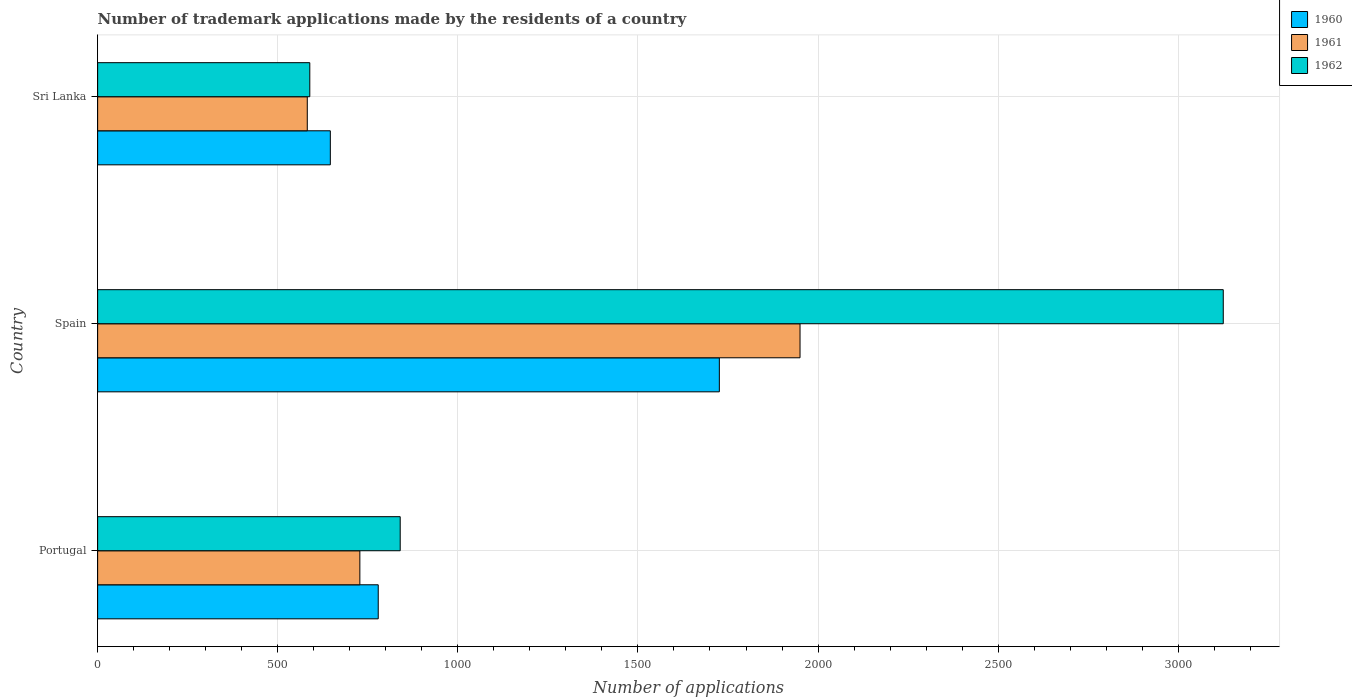How many different coloured bars are there?
Provide a short and direct response. 3. Are the number of bars per tick equal to the number of legend labels?
Ensure brevity in your answer.  Yes. Are the number of bars on each tick of the Y-axis equal?
Your answer should be compact. Yes. What is the label of the 3rd group of bars from the top?
Give a very brief answer. Portugal. In how many cases, is the number of bars for a given country not equal to the number of legend labels?
Offer a very short reply. 0. What is the number of trademark applications made by the residents in 1962 in Sri Lanka?
Offer a very short reply. 589. Across all countries, what is the maximum number of trademark applications made by the residents in 1962?
Ensure brevity in your answer.  3125. Across all countries, what is the minimum number of trademark applications made by the residents in 1962?
Offer a terse response. 589. In which country was the number of trademark applications made by the residents in 1962 maximum?
Ensure brevity in your answer.  Spain. In which country was the number of trademark applications made by the residents in 1961 minimum?
Make the answer very short. Sri Lanka. What is the total number of trademark applications made by the residents in 1961 in the graph?
Give a very brief answer. 3260. What is the difference between the number of trademark applications made by the residents in 1961 in Spain and that in Sri Lanka?
Provide a short and direct response. 1368. What is the difference between the number of trademark applications made by the residents in 1962 in Sri Lanka and the number of trademark applications made by the residents in 1960 in Portugal?
Provide a succinct answer. -190. What is the average number of trademark applications made by the residents in 1962 per country?
Provide a short and direct response. 1518. What is the difference between the number of trademark applications made by the residents in 1961 and number of trademark applications made by the residents in 1960 in Portugal?
Your answer should be very brief. -51. In how many countries, is the number of trademark applications made by the residents in 1962 greater than 1900 ?
Ensure brevity in your answer.  1. What is the ratio of the number of trademark applications made by the residents in 1961 in Portugal to that in Sri Lanka?
Keep it short and to the point. 1.25. Is the difference between the number of trademark applications made by the residents in 1961 in Spain and Sri Lanka greater than the difference between the number of trademark applications made by the residents in 1960 in Spain and Sri Lanka?
Keep it short and to the point. Yes. What is the difference between the highest and the second highest number of trademark applications made by the residents in 1960?
Ensure brevity in your answer.  947. What is the difference between the highest and the lowest number of trademark applications made by the residents in 1962?
Provide a short and direct response. 2536. In how many countries, is the number of trademark applications made by the residents in 1960 greater than the average number of trademark applications made by the residents in 1960 taken over all countries?
Your response must be concise. 1. Is the sum of the number of trademark applications made by the residents in 1962 in Portugal and Spain greater than the maximum number of trademark applications made by the residents in 1961 across all countries?
Your response must be concise. Yes. What does the 1st bar from the top in Spain represents?
Offer a very short reply. 1962. Is it the case that in every country, the sum of the number of trademark applications made by the residents in 1960 and number of trademark applications made by the residents in 1962 is greater than the number of trademark applications made by the residents in 1961?
Give a very brief answer. Yes. How many bars are there?
Your answer should be compact. 9. Are all the bars in the graph horizontal?
Your answer should be compact. Yes. What is the difference between two consecutive major ticks on the X-axis?
Make the answer very short. 500. Does the graph contain any zero values?
Give a very brief answer. No. Does the graph contain grids?
Offer a terse response. Yes. How many legend labels are there?
Your response must be concise. 3. What is the title of the graph?
Keep it short and to the point. Number of trademark applications made by the residents of a country. What is the label or title of the X-axis?
Your answer should be compact. Number of applications. What is the label or title of the Y-axis?
Give a very brief answer. Country. What is the Number of applications in 1960 in Portugal?
Keep it short and to the point. 779. What is the Number of applications of 1961 in Portugal?
Your answer should be very brief. 728. What is the Number of applications of 1962 in Portugal?
Offer a very short reply. 840. What is the Number of applications of 1960 in Spain?
Give a very brief answer. 1726. What is the Number of applications in 1961 in Spain?
Make the answer very short. 1950. What is the Number of applications in 1962 in Spain?
Ensure brevity in your answer.  3125. What is the Number of applications of 1960 in Sri Lanka?
Provide a short and direct response. 646. What is the Number of applications in 1961 in Sri Lanka?
Offer a very short reply. 582. What is the Number of applications of 1962 in Sri Lanka?
Ensure brevity in your answer.  589. Across all countries, what is the maximum Number of applications of 1960?
Make the answer very short. 1726. Across all countries, what is the maximum Number of applications of 1961?
Provide a succinct answer. 1950. Across all countries, what is the maximum Number of applications of 1962?
Your response must be concise. 3125. Across all countries, what is the minimum Number of applications in 1960?
Your answer should be very brief. 646. Across all countries, what is the minimum Number of applications in 1961?
Your answer should be compact. 582. Across all countries, what is the minimum Number of applications in 1962?
Your answer should be very brief. 589. What is the total Number of applications of 1960 in the graph?
Make the answer very short. 3151. What is the total Number of applications of 1961 in the graph?
Make the answer very short. 3260. What is the total Number of applications in 1962 in the graph?
Your response must be concise. 4554. What is the difference between the Number of applications in 1960 in Portugal and that in Spain?
Provide a short and direct response. -947. What is the difference between the Number of applications in 1961 in Portugal and that in Spain?
Provide a short and direct response. -1222. What is the difference between the Number of applications in 1962 in Portugal and that in Spain?
Offer a terse response. -2285. What is the difference between the Number of applications in 1960 in Portugal and that in Sri Lanka?
Keep it short and to the point. 133. What is the difference between the Number of applications in 1961 in Portugal and that in Sri Lanka?
Your response must be concise. 146. What is the difference between the Number of applications of 1962 in Portugal and that in Sri Lanka?
Offer a very short reply. 251. What is the difference between the Number of applications in 1960 in Spain and that in Sri Lanka?
Your answer should be compact. 1080. What is the difference between the Number of applications in 1961 in Spain and that in Sri Lanka?
Ensure brevity in your answer.  1368. What is the difference between the Number of applications in 1962 in Spain and that in Sri Lanka?
Offer a terse response. 2536. What is the difference between the Number of applications in 1960 in Portugal and the Number of applications in 1961 in Spain?
Your answer should be compact. -1171. What is the difference between the Number of applications of 1960 in Portugal and the Number of applications of 1962 in Spain?
Give a very brief answer. -2346. What is the difference between the Number of applications in 1961 in Portugal and the Number of applications in 1962 in Spain?
Your answer should be compact. -2397. What is the difference between the Number of applications in 1960 in Portugal and the Number of applications in 1961 in Sri Lanka?
Your answer should be very brief. 197. What is the difference between the Number of applications in 1960 in Portugal and the Number of applications in 1962 in Sri Lanka?
Give a very brief answer. 190. What is the difference between the Number of applications of 1961 in Portugal and the Number of applications of 1962 in Sri Lanka?
Keep it short and to the point. 139. What is the difference between the Number of applications of 1960 in Spain and the Number of applications of 1961 in Sri Lanka?
Give a very brief answer. 1144. What is the difference between the Number of applications in 1960 in Spain and the Number of applications in 1962 in Sri Lanka?
Make the answer very short. 1137. What is the difference between the Number of applications in 1961 in Spain and the Number of applications in 1962 in Sri Lanka?
Provide a short and direct response. 1361. What is the average Number of applications in 1960 per country?
Make the answer very short. 1050.33. What is the average Number of applications of 1961 per country?
Your response must be concise. 1086.67. What is the average Number of applications of 1962 per country?
Offer a terse response. 1518. What is the difference between the Number of applications in 1960 and Number of applications in 1962 in Portugal?
Keep it short and to the point. -61. What is the difference between the Number of applications of 1961 and Number of applications of 1962 in Portugal?
Ensure brevity in your answer.  -112. What is the difference between the Number of applications of 1960 and Number of applications of 1961 in Spain?
Provide a short and direct response. -224. What is the difference between the Number of applications of 1960 and Number of applications of 1962 in Spain?
Provide a short and direct response. -1399. What is the difference between the Number of applications of 1961 and Number of applications of 1962 in Spain?
Provide a short and direct response. -1175. What is the difference between the Number of applications in 1961 and Number of applications in 1962 in Sri Lanka?
Make the answer very short. -7. What is the ratio of the Number of applications in 1960 in Portugal to that in Spain?
Your answer should be compact. 0.45. What is the ratio of the Number of applications of 1961 in Portugal to that in Spain?
Offer a very short reply. 0.37. What is the ratio of the Number of applications of 1962 in Portugal to that in Spain?
Keep it short and to the point. 0.27. What is the ratio of the Number of applications in 1960 in Portugal to that in Sri Lanka?
Provide a short and direct response. 1.21. What is the ratio of the Number of applications of 1961 in Portugal to that in Sri Lanka?
Keep it short and to the point. 1.25. What is the ratio of the Number of applications of 1962 in Portugal to that in Sri Lanka?
Make the answer very short. 1.43. What is the ratio of the Number of applications of 1960 in Spain to that in Sri Lanka?
Offer a terse response. 2.67. What is the ratio of the Number of applications in 1961 in Spain to that in Sri Lanka?
Ensure brevity in your answer.  3.35. What is the ratio of the Number of applications in 1962 in Spain to that in Sri Lanka?
Give a very brief answer. 5.31. What is the difference between the highest and the second highest Number of applications in 1960?
Offer a terse response. 947. What is the difference between the highest and the second highest Number of applications of 1961?
Give a very brief answer. 1222. What is the difference between the highest and the second highest Number of applications of 1962?
Offer a very short reply. 2285. What is the difference between the highest and the lowest Number of applications of 1960?
Your answer should be compact. 1080. What is the difference between the highest and the lowest Number of applications in 1961?
Give a very brief answer. 1368. What is the difference between the highest and the lowest Number of applications in 1962?
Provide a short and direct response. 2536. 